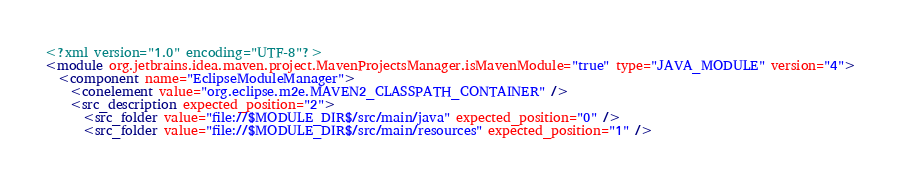<code> <loc_0><loc_0><loc_500><loc_500><_XML_><?xml version="1.0" encoding="UTF-8"?>
<module org.jetbrains.idea.maven.project.MavenProjectsManager.isMavenModule="true" type="JAVA_MODULE" version="4">
  <component name="EclipseModuleManager">
    <conelement value="org.eclipse.m2e.MAVEN2_CLASSPATH_CONTAINER" />
    <src_description expected_position="2">
      <src_folder value="file://$MODULE_DIR$/src/main/java" expected_position="0" />
      <src_folder value="file://$MODULE_DIR$/src/main/resources" expected_position="1" /></code> 